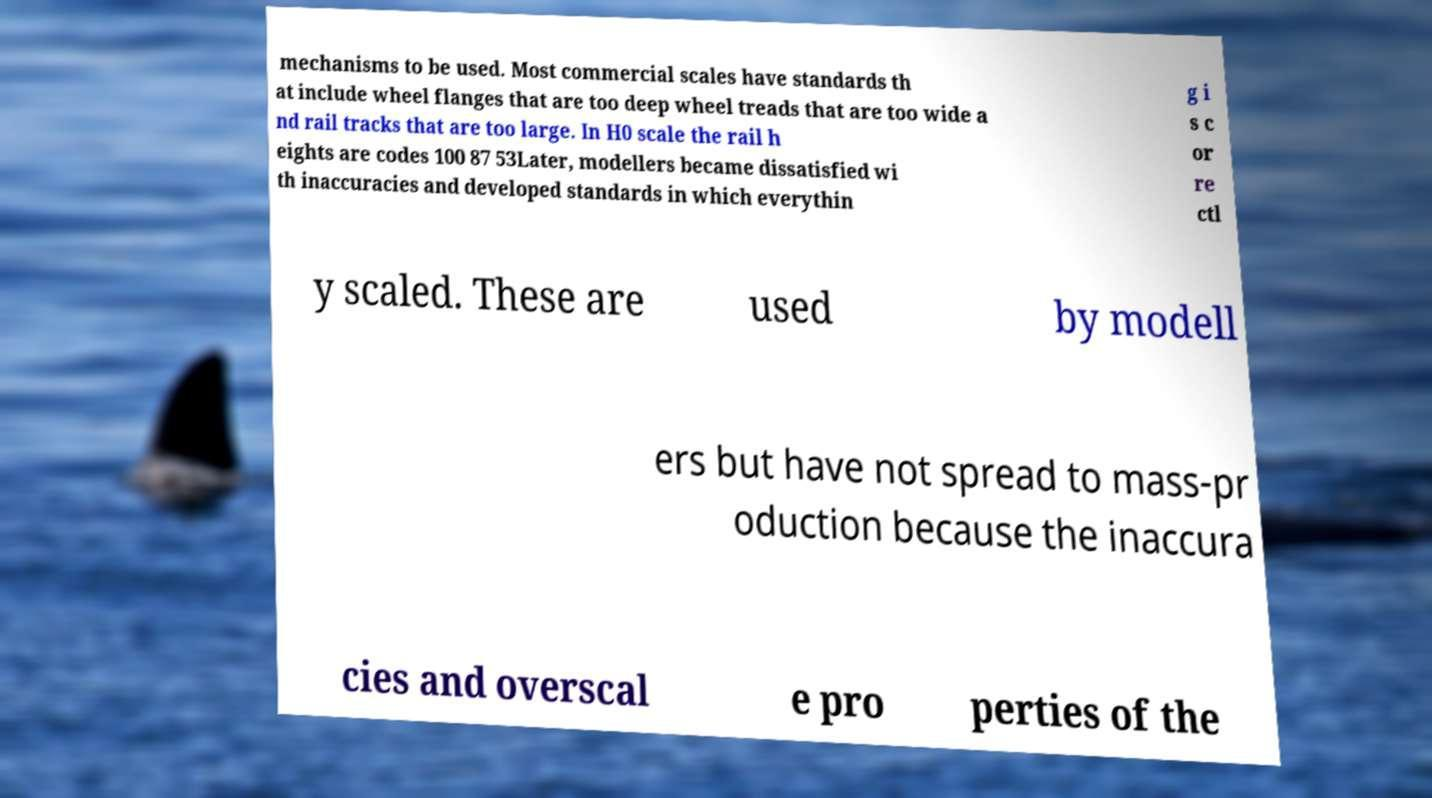Can you accurately transcribe the text from the provided image for me? mechanisms to be used. Most commercial scales have standards th at include wheel flanges that are too deep wheel treads that are too wide a nd rail tracks that are too large. In H0 scale the rail h eights are codes 100 87 53Later, modellers became dissatisfied wi th inaccuracies and developed standards in which everythin g i s c or re ctl y scaled. These are used by modell ers but have not spread to mass-pr oduction because the inaccura cies and overscal e pro perties of the 